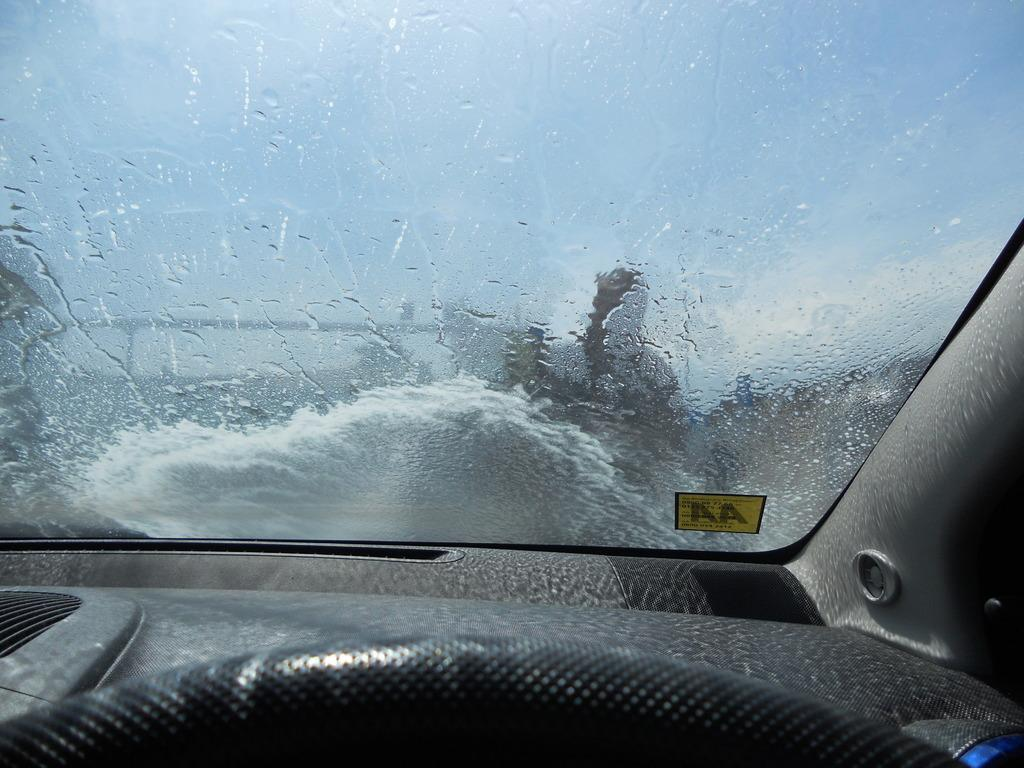What type of setting is depicted in the image? The image is an inside view of a car. What can be seen through the front of the car? There is a windshield visible in the image. What part of the car is visible in the image? The dashboard is present in the image. What is used for steering the car? The steering wheel is visible in the image. Can you see a baby sitting in a vest in the image? There is no baby or vest present in the image; it is an inside view of a car with a focus on the windshield, dashboard, and steering wheel. 